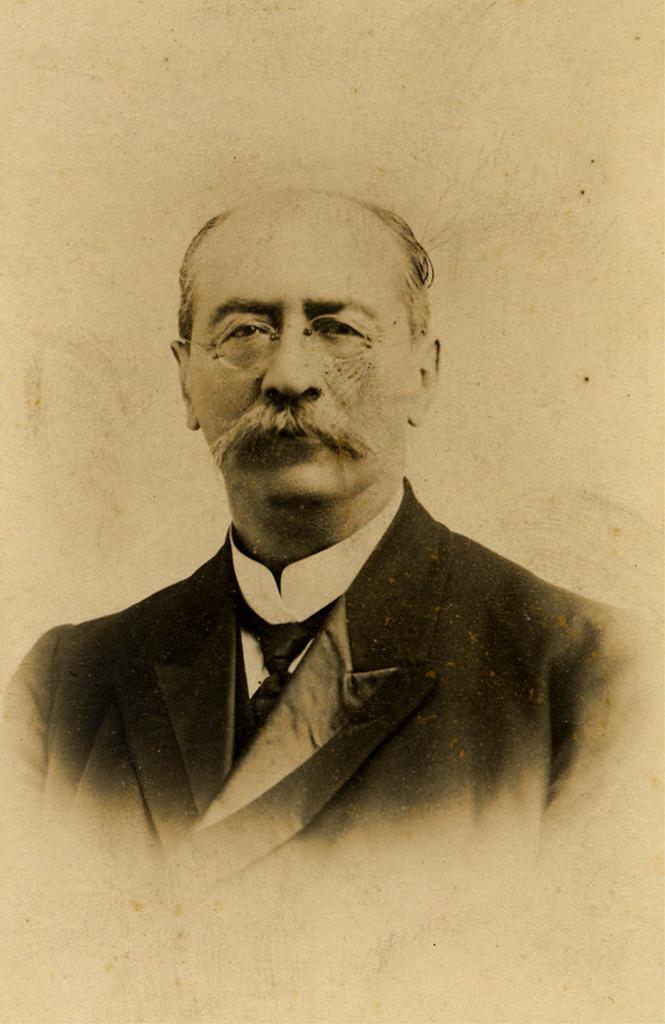Describe this image in one or two sentences. In this image I can see the person and the person is wearing the blazer, shirt and the tie and I can see the white color background. 